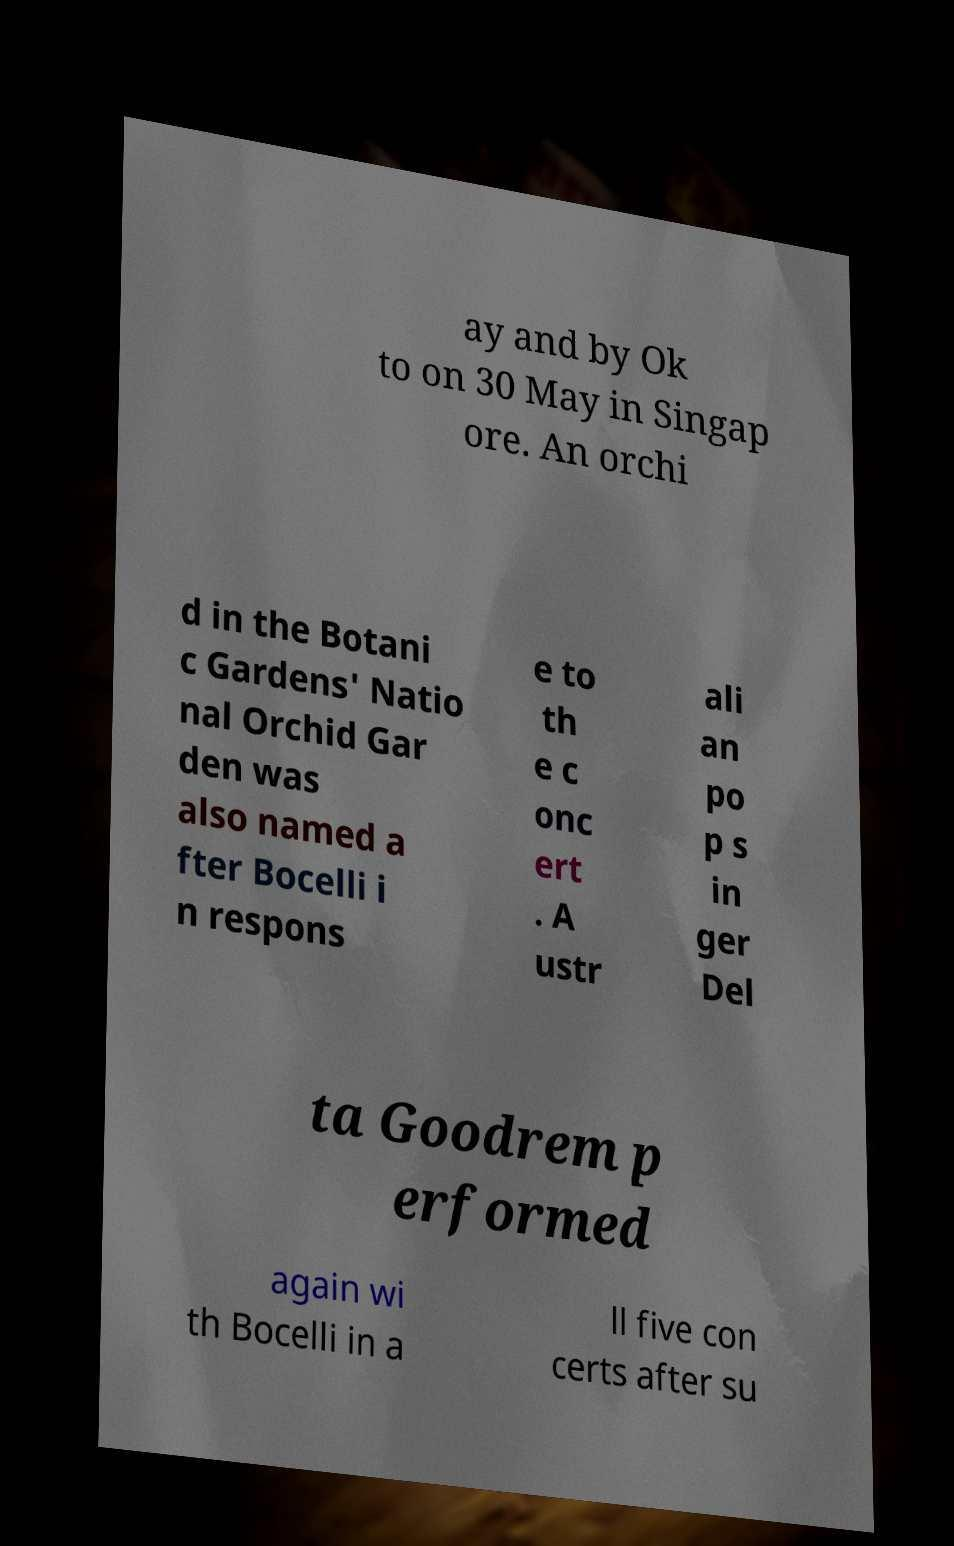For documentation purposes, I need the text within this image transcribed. Could you provide that? ay and by Ok to on 30 May in Singap ore. An orchi d in the Botani c Gardens' Natio nal Orchid Gar den was also named a fter Bocelli i n respons e to th e c onc ert . A ustr ali an po p s in ger Del ta Goodrem p erformed again wi th Bocelli in a ll five con certs after su 